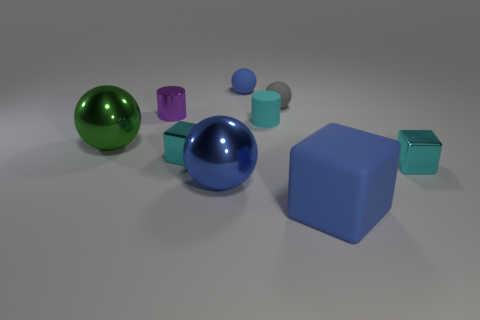What is the small purple object behind the green ball, and what is its purpose? The small purple object appears to be a hollow cylinder or a ring positioned upright behind the green ball. Its reflective surface and open center suggest it could be an object used for visual or aesthetic purposes, like a decoration or part of a set for displaying objects. Its role seems to be purely ornamental since it doesn't appear to have any function beyond contributing to the scene's symmetry and color balance. 